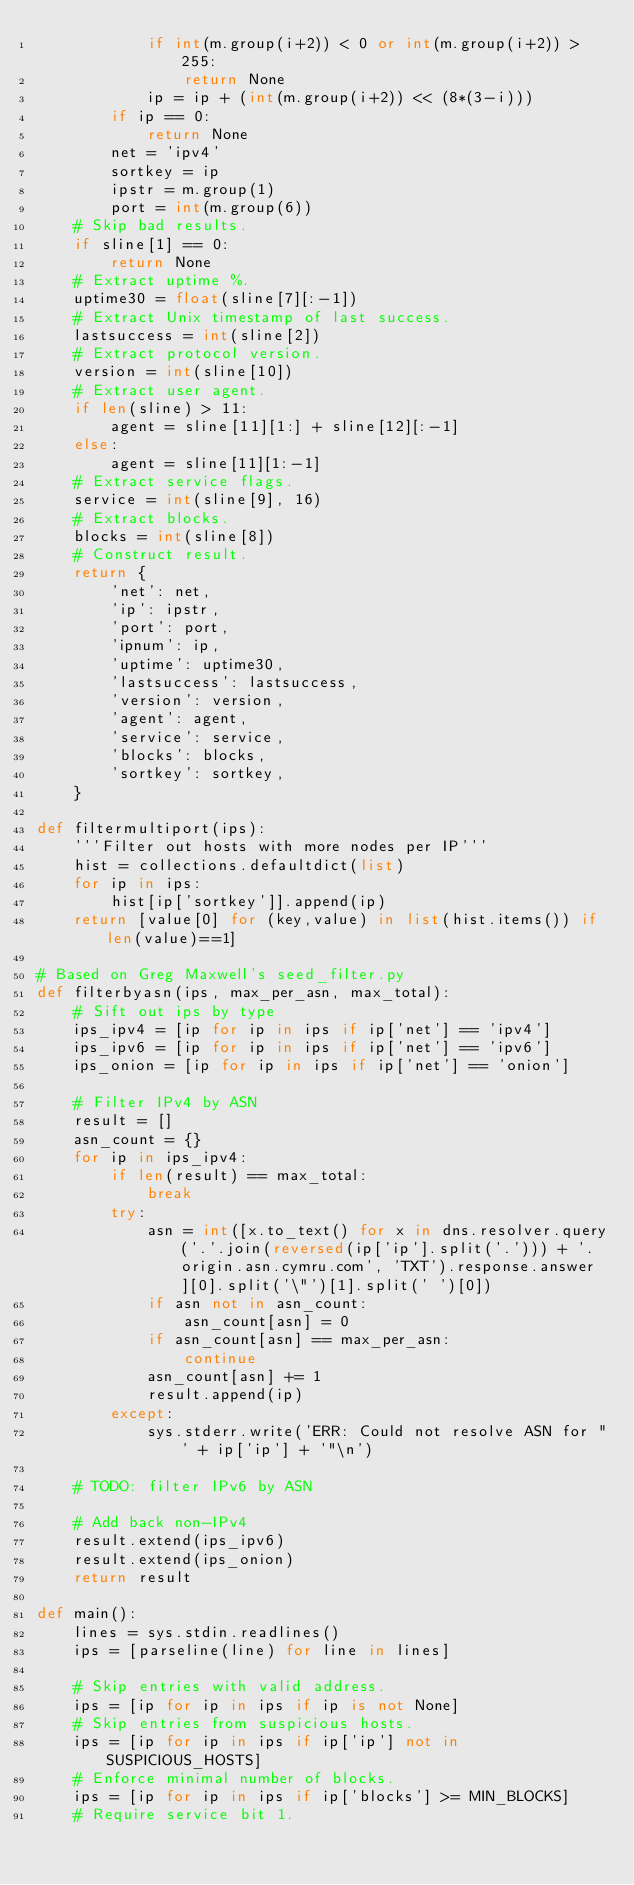Convert code to text. <code><loc_0><loc_0><loc_500><loc_500><_Python_>            if int(m.group(i+2)) < 0 or int(m.group(i+2)) > 255:
                return None
            ip = ip + (int(m.group(i+2)) << (8*(3-i)))
        if ip == 0:
            return None
        net = 'ipv4'
        sortkey = ip
        ipstr = m.group(1)
        port = int(m.group(6))
    # Skip bad results.
    if sline[1] == 0:
        return None
    # Extract uptime %.
    uptime30 = float(sline[7][:-1])
    # Extract Unix timestamp of last success.
    lastsuccess = int(sline[2])
    # Extract protocol version.
    version = int(sline[10])
    # Extract user agent.
    if len(sline) > 11:
        agent = sline[11][1:] + sline[12][:-1]
    else:
        agent = sline[11][1:-1]
    # Extract service flags.
    service = int(sline[9], 16)
    # Extract blocks.
    blocks = int(sline[8])
    # Construct result.
    return {
        'net': net,
        'ip': ipstr,
        'port': port,
        'ipnum': ip,
        'uptime': uptime30,
        'lastsuccess': lastsuccess,
        'version': version,
        'agent': agent,
        'service': service,
        'blocks': blocks,
        'sortkey': sortkey,
    }

def filtermultiport(ips):
    '''Filter out hosts with more nodes per IP'''
    hist = collections.defaultdict(list)
    for ip in ips:
        hist[ip['sortkey']].append(ip)
    return [value[0] for (key,value) in list(hist.items()) if len(value)==1]

# Based on Greg Maxwell's seed_filter.py
def filterbyasn(ips, max_per_asn, max_total):
    # Sift out ips by type
    ips_ipv4 = [ip for ip in ips if ip['net'] == 'ipv4']
    ips_ipv6 = [ip for ip in ips if ip['net'] == 'ipv6']
    ips_onion = [ip for ip in ips if ip['net'] == 'onion']

    # Filter IPv4 by ASN
    result = []
    asn_count = {}
    for ip in ips_ipv4:
        if len(result) == max_total:
            break
        try:
            asn = int([x.to_text() for x in dns.resolver.query('.'.join(reversed(ip['ip'].split('.'))) + '.origin.asn.cymru.com', 'TXT').response.answer][0].split('\"')[1].split(' ')[0])
            if asn not in asn_count:
                asn_count[asn] = 0
            if asn_count[asn] == max_per_asn:
                continue
            asn_count[asn] += 1
            result.append(ip)
        except:
            sys.stderr.write('ERR: Could not resolve ASN for "' + ip['ip'] + '"\n')

    # TODO: filter IPv6 by ASN

    # Add back non-IPv4
    result.extend(ips_ipv6)
    result.extend(ips_onion)
    return result

def main():
    lines = sys.stdin.readlines()
    ips = [parseline(line) for line in lines]

    # Skip entries with valid address.
    ips = [ip for ip in ips if ip is not None]
    # Skip entries from suspicious hosts.
    ips = [ip for ip in ips if ip['ip'] not in SUSPICIOUS_HOSTS]
    # Enforce minimal number of blocks.
    ips = [ip for ip in ips if ip['blocks'] >= MIN_BLOCKS]
    # Require service bit 1.</code> 